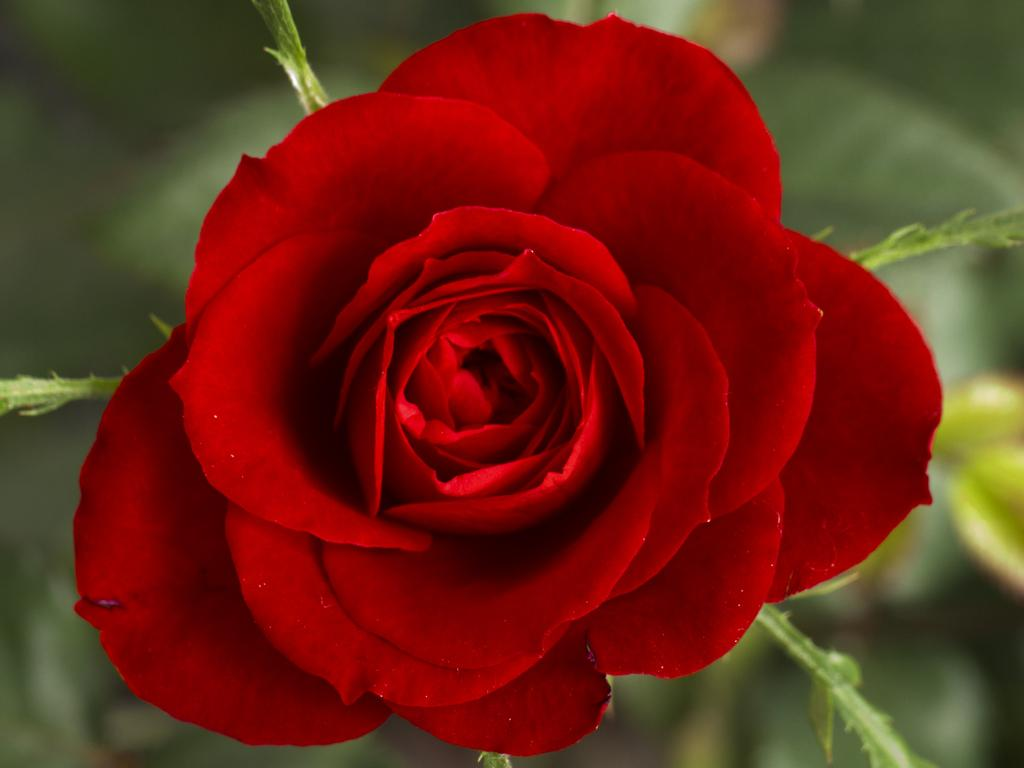What type of flower is in the image? There is a red flower in the image. What is the flower connected to? The flower is attached to a green plant. What color is the background of the image? The background of the image is green and blurry. Can you see any goldfish swimming in the image? There are no goldfish present in the image. What type of cloud is visible in the image? There is no cloud visible in the image; the background is green and blurry. 